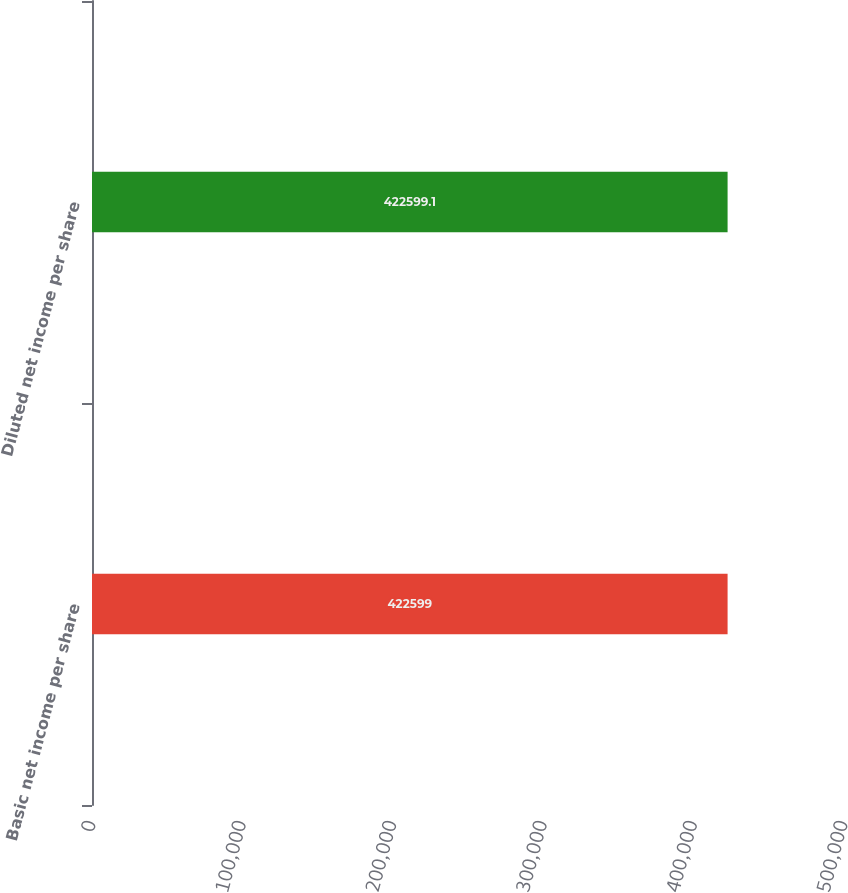Convert chart to OTSL. <chart><loc_0><loc_0><loc_500><loc_500><bar_chart><fcel>Basic net income per share<fcel>Diluted net income per share<nl><fcel>422599<fcel>422599<nl></chart> 